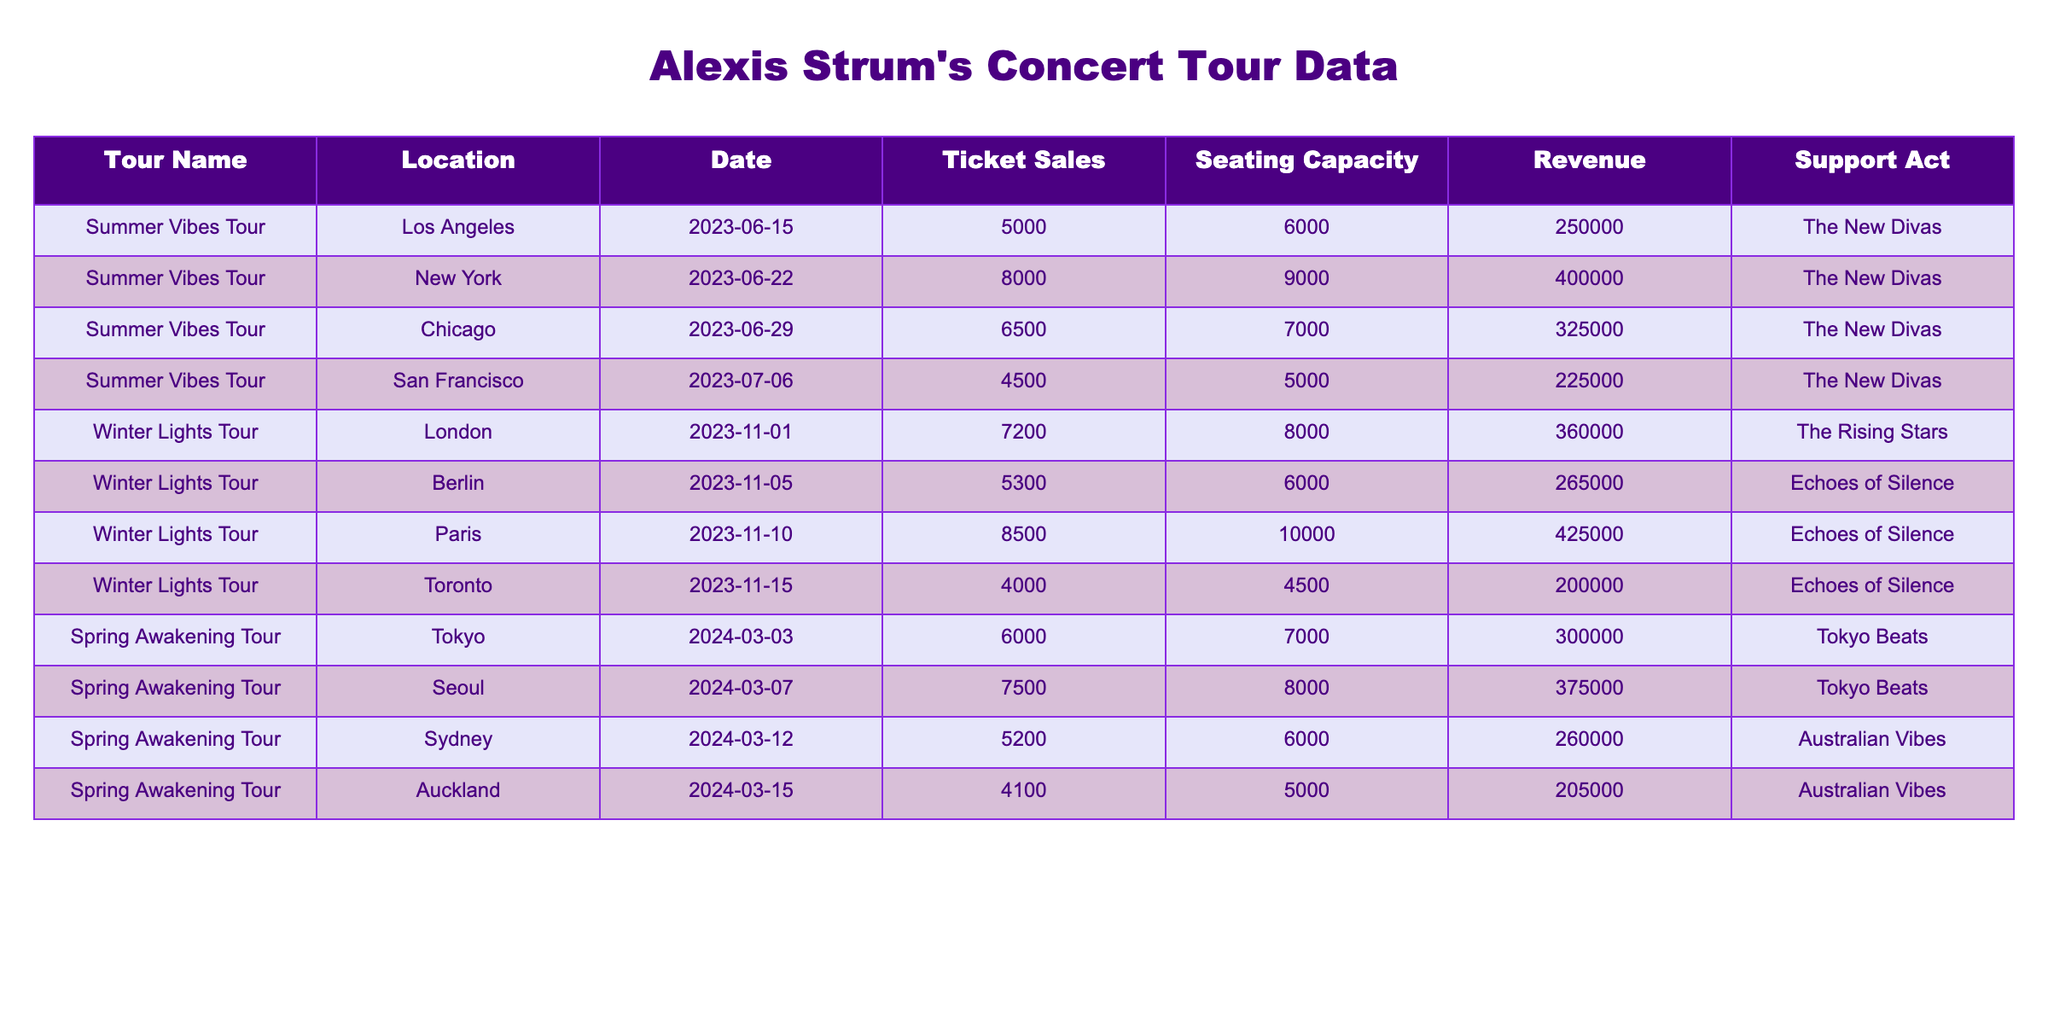What is the total ticket sales for the Summer Vibes Tour? For the Summer Vibes Tour, the ticket sales are 5000 (Los Angeles) + 8000 (New York) + 6500 (Chicago) + 4500 (San Francisco), resulting in a total of 5000 + 8000 + 6500 + 4500 = 24000.
Answer: 24000 Which location had the highest ticket sales in the Winter Lights Tour? In the Winter Lights Tour, the ticket sales are as follows: 7200 (London), 5300 (Berlin), 8500 (Paris), and 4000 (Toronto). The highest among these is 8500 in Paris.
Answer: Paris What was the revenue generated from the concert in Sydney during the Spring Awakening Tour? The revenue generated from the Spring Awakening Tour concert in Sydney is directly listed in the table as 260000.
Answer: 260000 Did the support act for the Summer Vibes Tour perform in all locations? The support act for the Summer Vibes Tour is The New Divas, which is provided for each location in the table, confirming that they performed at all locations listed.
Answer: Yes What is the average ticket sales for the Spring Awakening Tour? The ticket sales for the Spring Awakening Tour are 6000 (Tokyo), 7500 (Seoul), 5200 (Sydney), and 4100 (Auckland). To find the average, add them up: 6000 + 7500 + 5200 + 4100 = 22800. Then divide by 4 (the number of concerts): 22800 / 4 = 5700.
Answer: 5700 Which tour had the lowest seating capacity overall? Assessing the seating capacities from the table: 6000 (Los Angeles), 9000 (New York), 7000 (Chicago), 5000 (San Francisco), 8000 (London), 6000 (Berlin), 10000 (Paris), 4500 (Toronto), 7000 (Tokyo), 8000 (Seoul), 6000 (Sydney), and 5000 (Auckland). The lowest capacity is 4500 in Toronto.
Answer: Toronto How much revenue was generated in total for the Winter Lights Tour? The revenue for each concert in the Winter Lights Tour are: 360000 (London), 265000 (Berlin), 425000 (Paris), and 200000 (Toronto). Adding these together gives 360000 + 265000 + 425000 + 200000 = 1250000.
Answer: 1250000 What was the ticket sales difference between the highest and lowest sales in the Summer Vibes Tour? The highest ticket sales in the Summer Vibes Tour is 8000 in New York and the lowest is 4500 in San Francisco. The difference is calculated as 8000 - 4500 = 3500.
Answer: 3500 Which tour had the most concerts? Counting the number of concerts from the table, the Summer Vibes Tour has 4 concerts, the Winter Lights Tour has 4 concerts, and the Spring Awakening Tour also has 4 concerts. Since all tours had equal numbers, none of them has more than the others.
Answer: None In which city did the Spring Awakening Tour perform at the lowest seating capacity? The seating capacities for the Spring Awakening Tour are: 7000 (Tokyo), 8000 (Seoul), 6000 (Sydney), and 5000 (Auckland). The lowest is in Auckland, which has a seating capacity of 5000.
Answer: Auckland 